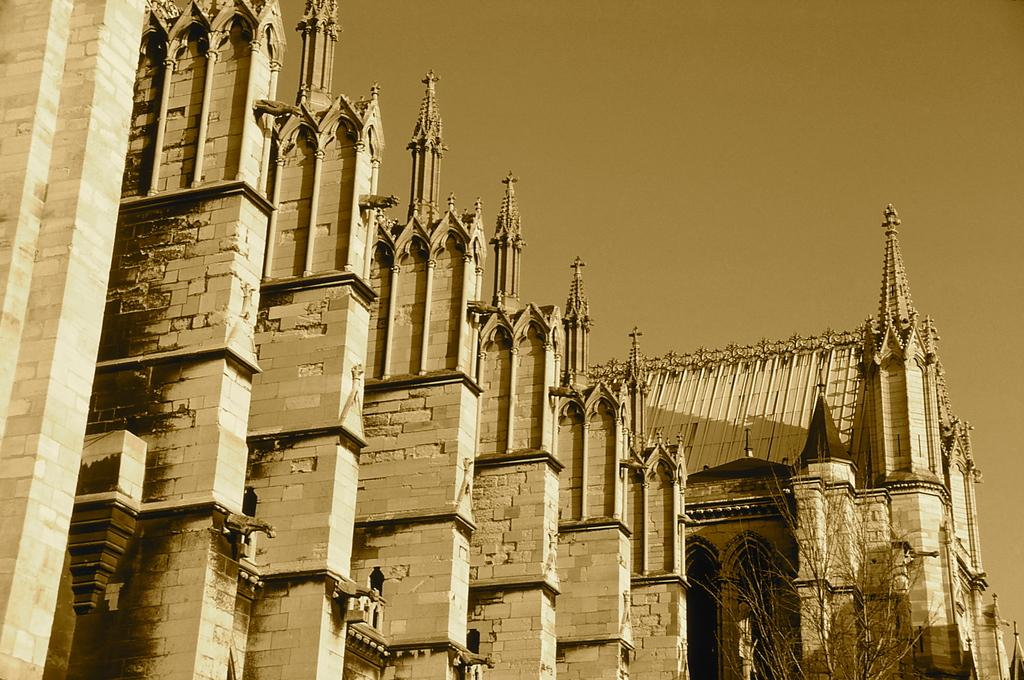What type of structures are present in the image? There are buildings in the image. Can you describe any specific features of the buildings? Yes, there are towers on the buildings. What is the condition of the plant near the buildings? The plant near the buildings appears to be dry. What can be seen in the background of the image? The sky is visible in the background of the image. What type of agreement is being discussed by the buildings in the image? There are no people or discussions depicted in the image, so it is not possible to determine if an agreement is being discussed. 